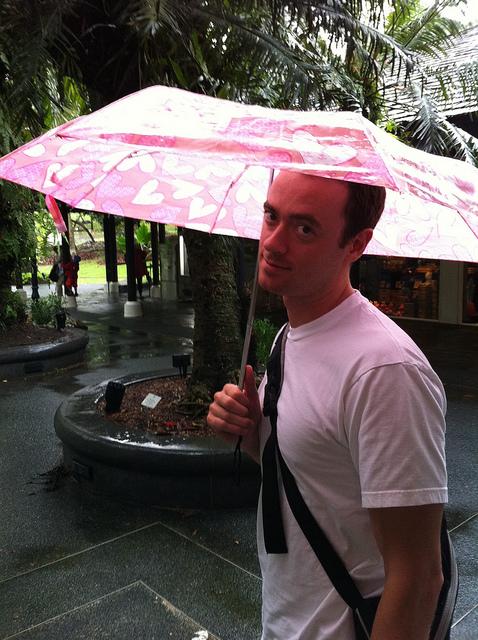What color is the umbrella?
Keep it brief. Pink. Is this man angry?
Answer briefly. No. Which hand holds the umbrella?
Give a very brief answer. Right. 